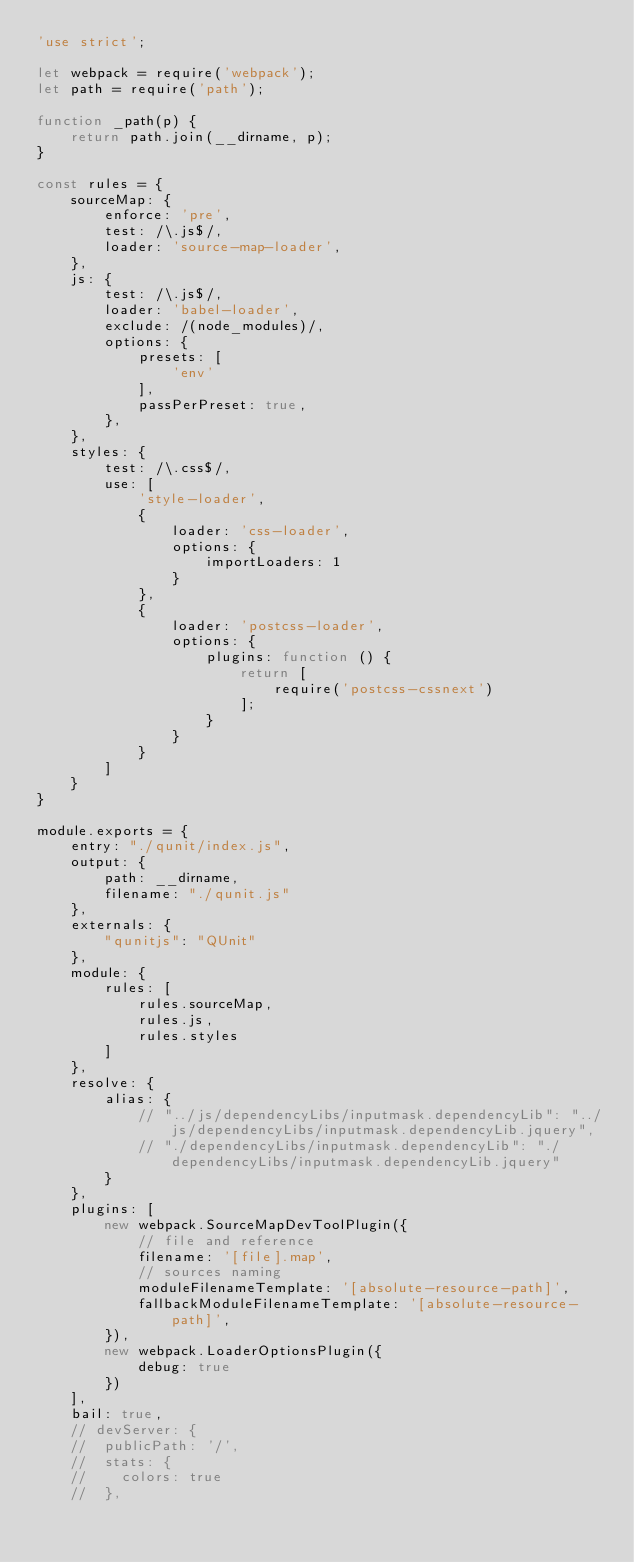Convert code to text. <code><loc_0><loc_0><loc_500><loc_500><_JavaScript_>'use strict';

let webpack = require('webpack');
let path = require('path');

function _path(p) {
    return path.join(__dirname, p);
}

const rules = {
    sourceMap: {
        enforce: 'pre',
        test: /\.js$/,
        loader: 'source-map-loader',
    },
    js: {
        test: /\.js$/,
        loader: 'babel-loader',
        exclude: /(node_modules)/,
        options: {
            presets: [
                'env'
            ],
            passPerPreset: true,
        },
    },
    styles: {
        test: /\.css$/,
        use: [
            'style-loader',
            {
                loader: 'css-loader',
                options: {
                    importLoaders: 1
                }
            },
            {
                loader: 'postcss-loader',
                options: {
                    plugins: function () {
                        return [
                            require('postcss-cssnext')
                        ];
                    }
                }
            }
        ]
    }
}

module.exports = {
    entry: "./qunit/index.js",
    output: {
        path: __dirname,
        filename: "./qunit.js"
    },
    externals: {
        "qunitjs": "QUnit"
    },
    module: {
        rules: [
            rules.sourceMap,
            rules.js,
            rules.styles
        ]
    },
    resolve: {
        alias: {
            // "../js/dependencyLibs/inputmask.dependencyLib": "../js/dependencyLibs/inputmask.dependencyLib.jquery",
            // "./dependencyLibs/inputmask.dependencyLib": "./dependencyLibs/inputmask.dependencyLib.jquery"
        }
    },
    plugins: [
        new webpack.SourceMapDevToolPlugin({
            // file and reference
            filename: '[file].map',
            // sources naming
            moduleFilenameTemplate: '[absolute-resource-path]',
            fallbackModuleFilenameTemplate: '[absolute-resource-path]',
        }),
        new webpack.LoaderOptionsPlugin({
            debug: true
        })
    ],
    bail: true,
    // devServer: {
    // 	publicPath: '/',
    // 	stats: {
    // 		colors: true
    // 	},</code> 